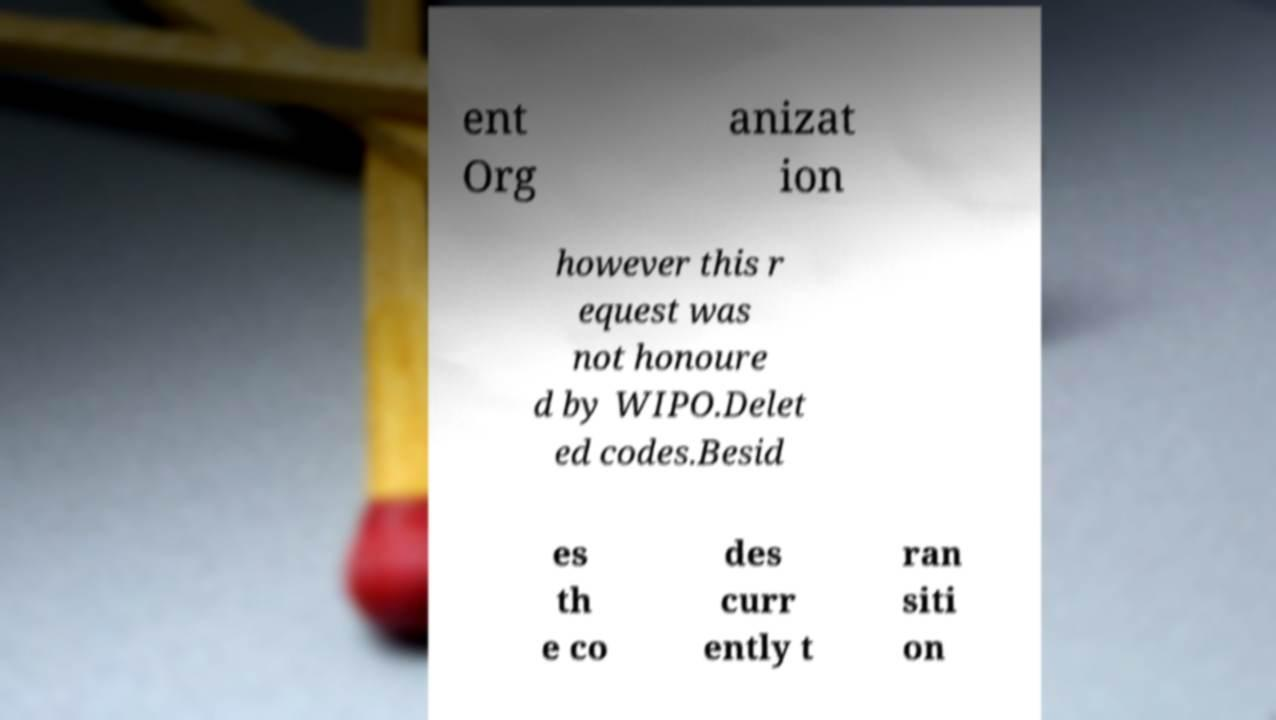Please identify and transcribe the text found in this image. ent Org anizat ion however this r equest was not honoure d by WIPO.Delet ed codes.Besid es th e co des curr ently t ran siti on 